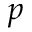<formula> <loc_0><loc_0><loc_500><loc_500>p</formula> 